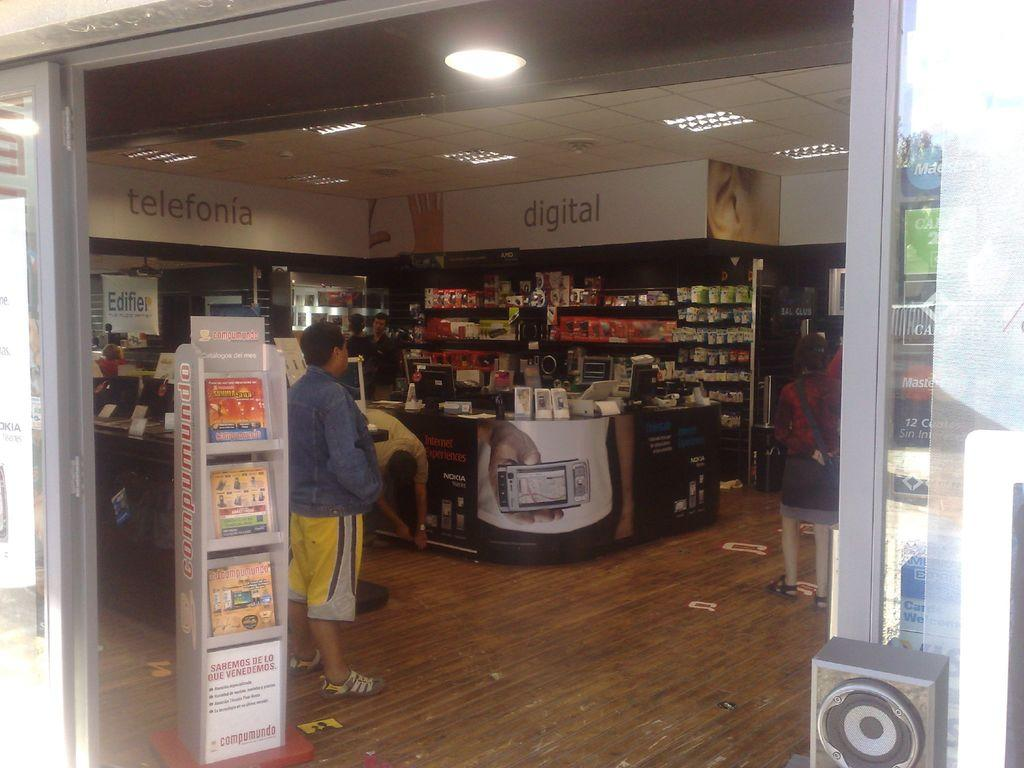What type of establishment is depicted in the image? There is a store in the image. What can be found inside the store? The store has items inside it. Are there any people present in the image? Yes, there is a group of people standing inside the store. What type of field can be seen in the background of the image? There is no field visible in the image; it features a store with items and people inside. What causes the burst of light in the image? There is no burst of light present in the image. 